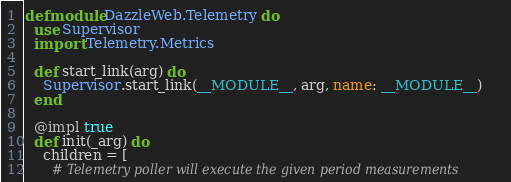<code> <loc_0><loc_0><loc_500><loc_500><_Elixir_>defmodule DazzleWeb.Telemetry do
  use Supervisor
  import Telemetry.Metrics

  def start_link(arg) do
    Supervisor.start_link(__MODULE__, arg, name: __MODULE__)
  end

  @impl true
  def init(_arg) do
    children = [
      # Telemetry poller will execute the given period measurements</code> 